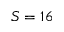<formula> <loc_0><loc_0><loc_500><loc_500>S = 1 6</formula> 